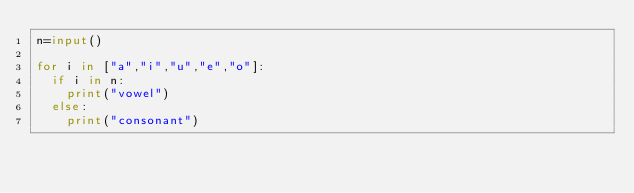Convert code to text. <code><loc_0><loc_0><loc_500><loc_500><_Python_>n=input()

for i in ["a","i","u","e","o"]:
  if i in n:
    print("vowel")
  else:
    print("consonant")</code> 